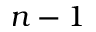Convert formula to latex. <formula><loc_0><loc_0><loc_500><loc_500>n - 1</formula> 